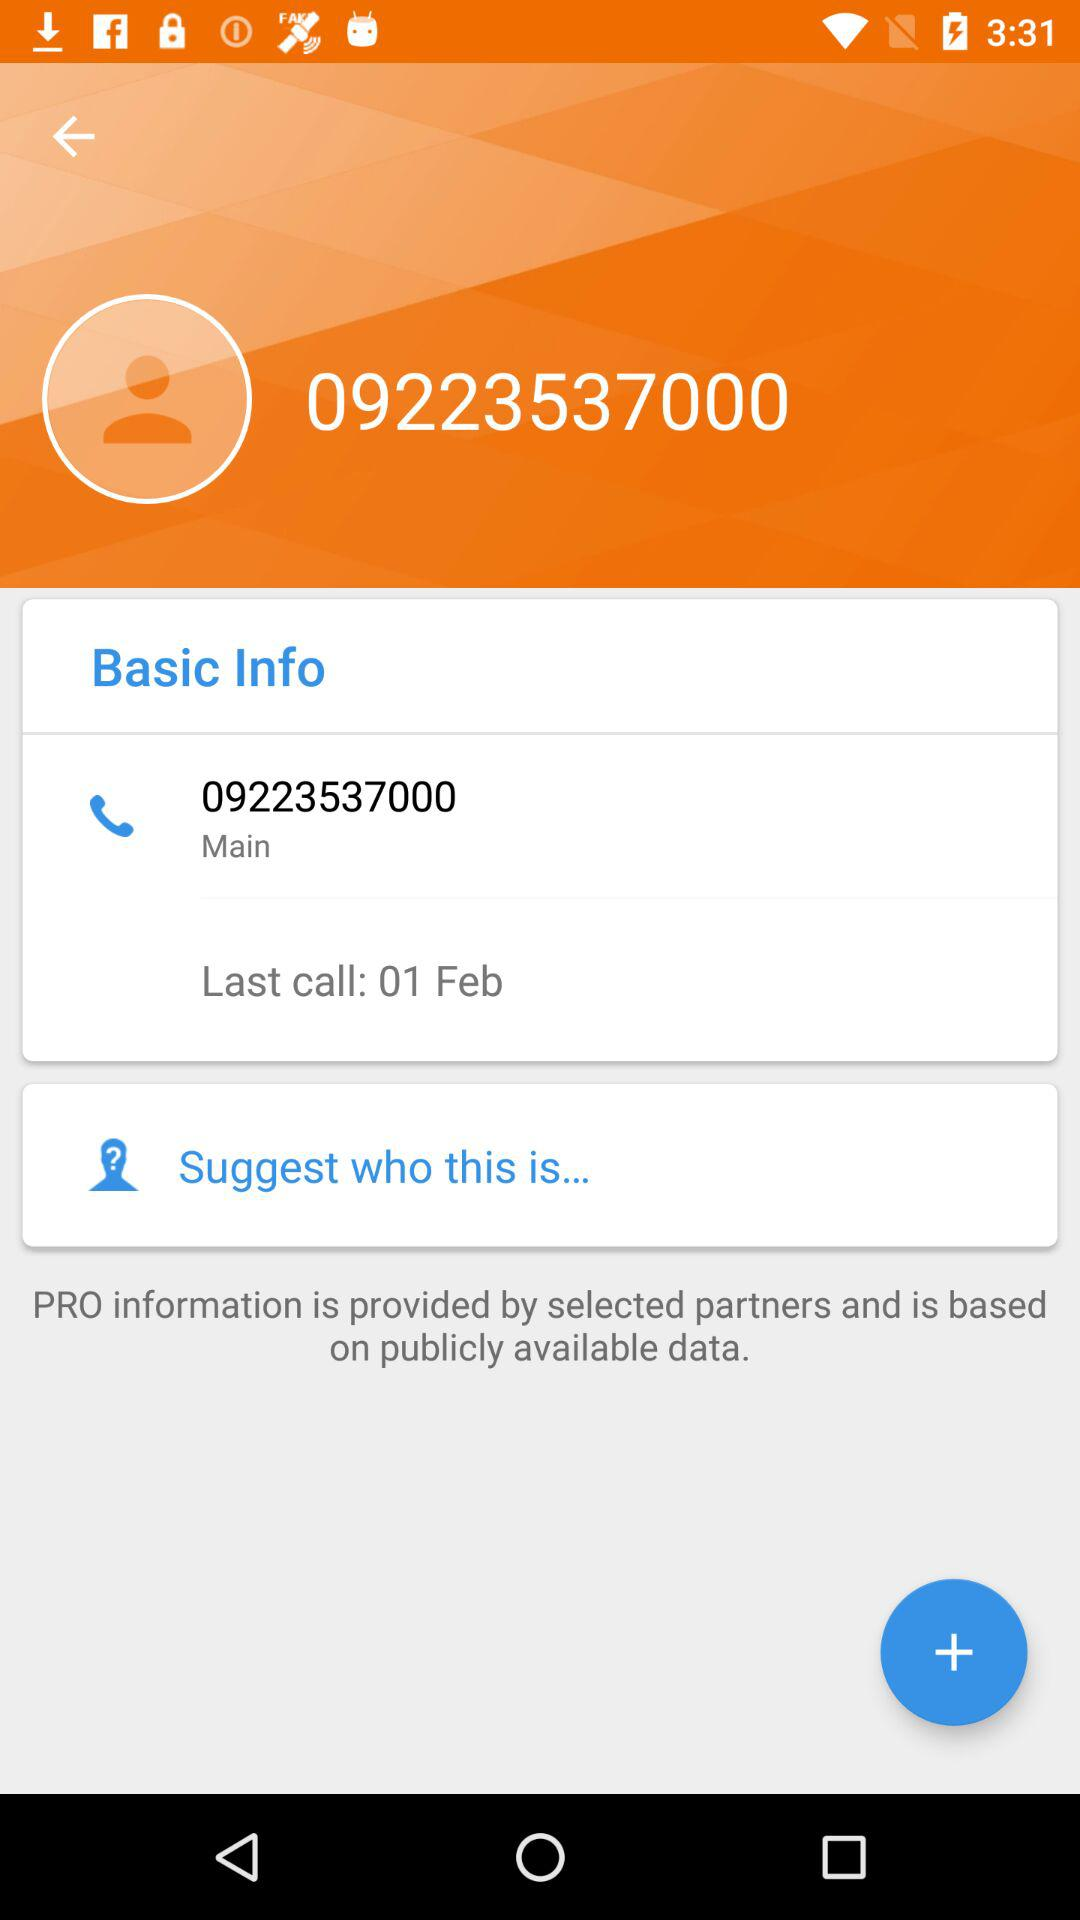What's the main contact number? The main contact number is 09223537000. 